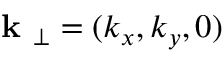<formula> <loc_0><loc_0><loc_500><loc_500>k _ { \perp } = ( k _ { x } , k _ { y } , 0 )</formula> 